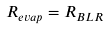Convert formula to latex. <formula><loc_0><loc_0><loc_500><loc_500>R _ { e v a p } = R _ { B L R }</formula> 